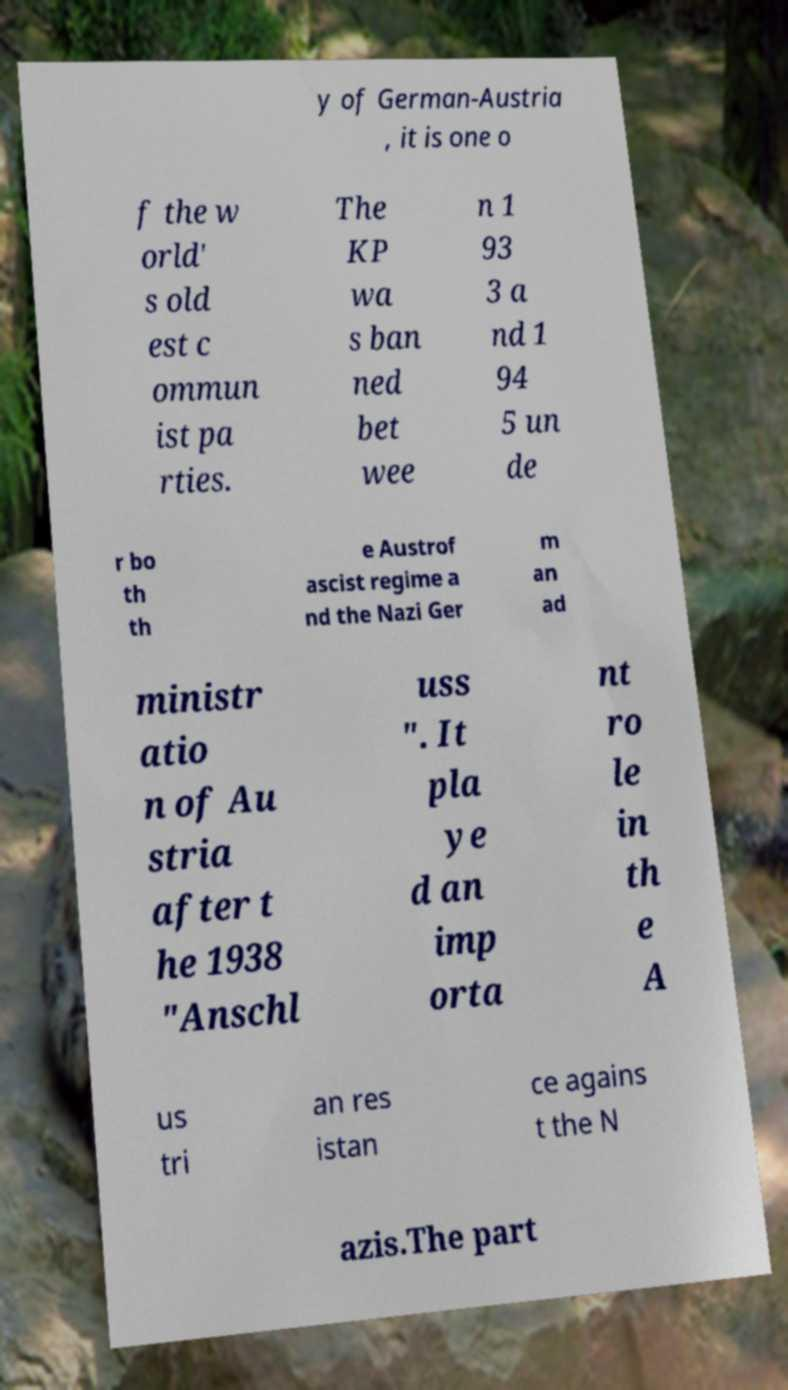Can you accurately transcribe the text from the provided image for me? y of German-Austria , it is one o f the w orld' s old est c ommun ist pa rties. The KP wa s ban ned bet wee n 1 93 3 a nd 1 94 5 un de r bo th th e Austrof ascist regime a nd the Nazi Ger m an ad ministr atio n of Au stria after t he 1938 "Anschl uss ". It pla ye d an imp orta nt ro le in th e A us tri an res istan ce agains t the N azis.The part 